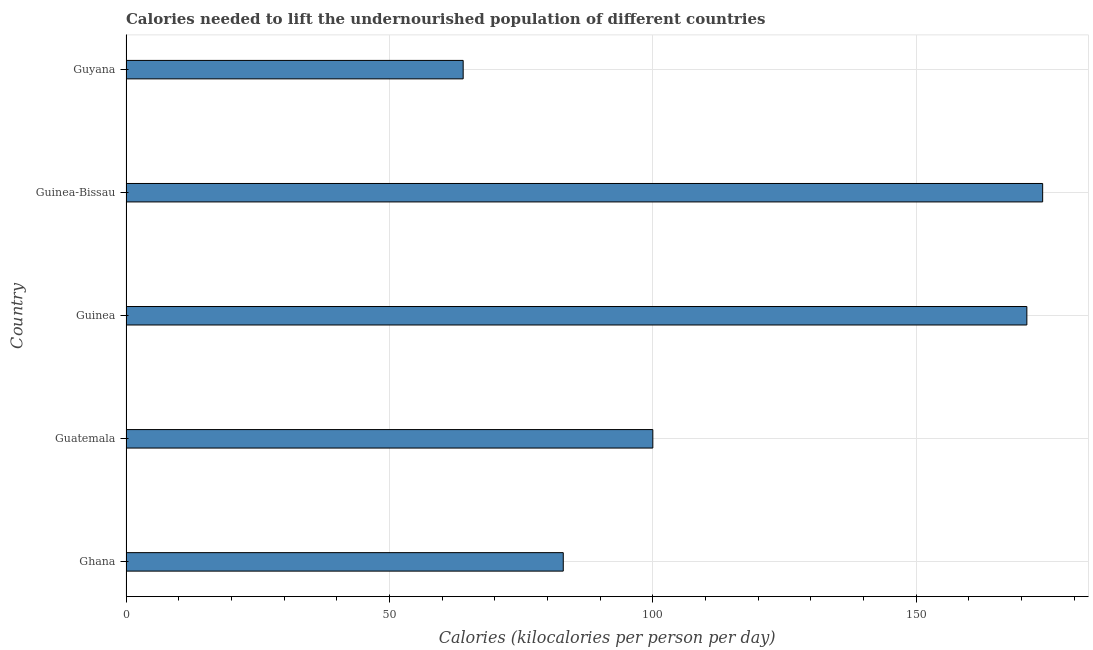Does the graph contain any zero values?
Offer a very short reply. No. What is the title of the graph?
Offer a terse response. Calories needed to lift the undernourished population of different countries. What is the label or title of the X-axis?
Provide a short and direct response. Calories (kilocalories per person per day). What is the label or title of the Y-axis?
Ensure brevity in your answer.  Country. What is the depth of food deficit in Guinea?
Provide a succinct answer. 171. Across all countries, what is the maximum depth of food deficit?
Make the answer very short. 174. Across all countries, what is the minimum depth of food deficit?
Keep it short and to the point. 64. In which country was the depth of food deficit maximum?
Your answer should be very brief. Guinea-Bissau. In which country was the depth of food deficit minimum?
Provide a succinct answer. Guyana. What is the sum of the depth of food deficit?
Offer a terse response. 592. What is the average depth of food deficit per country?
Offer a very short reply. 118.4. What is the ratio of the depth of food deficit in Guinea to that in Guyana?
Offer a very short reply. 2.67. Is the difference between the depth of food deficit in Guinea and Guinea-Bissau greater than the difference between any two countries?
Keep it short and to the point. No. Is the sum of the depth of food deficit in Ghana and Guinea-Bissau greater than the maximum depth of food deficit across all countries?
Give a very brief answer. Yes. What is the difference between the highest and the lowest depth of food deficit?
Your answer should be compact. 110. In how many countries, is the depth of food deficit greater than the average depth of food deficit taken over all countries?
Your response must be concise. 2. Are all the bars in the graph horizontal?
Offer a terse response. Yes. How many countries are there in the graph?
Provide a succinct answer. 5. What is the difference between two consecutive major ticks on the X-axis?
Give a very brief answer. 50. Are the values on the major ticks of X-axis written in scientific E-notation?
Your response must be concise. No. What is the Calories (kilocalories per person per day) of Guinea?
Your answer should be compact. 171. What is the Calories (kilocalories per person per day) in Guinea-Bissau?
Give a very brief answer. 174. What is the difference between the Calories (kilocalories per person per day) in Ghana and Guinea?
Make the answer very short. -88. What is the difference between the Calories (kilocalories per person per day) in Ghana and Guinea-Bissau?
Your answer should be very brief. -91. What is the difference between the Calories (kilocalories per person per day) in Ghana and Guyana?
Ensure brevity in your answer.  19. What is the difference between the Calories (kilocalories per person per day) in Guatemala and Guinea?
Offer a terse response. -71. What is the difference between the Calories (kilocalories per person per day) in Guatemala and Guinea-Bissau?
Offer a very short reply. -74. What is the difference between the Calories (kilocalories per person per day) in Guatemala and Guyana?
Provide a succinct answer. 36. What is the difference between the Calories (kilocalories per person per day) in Guinea and Guinea-Bissau?
Your answer should be very brief. -3. What is the difference between the Calories (kilocalories per person per day) in Guinea and Guyana?
Your response must be concise. 107. What is the difference between the Calories (kilocalories per person per day) in Guinea-Bissau and Guyana?
Your answer should be compact. 110. What is the ratio of the Calories (kilocalories per person per day) in Ghana to that in Guatemala?
Give a very brief answer. 0.83. What is the ratio of the Calories (kilocalories per person per day) in Ghana to that in Guinea?
Your answer should be very brief. 0.48. What is the ratio of the Calories (kilocalories per person per day) in Ghana to that in Guinea-Bissau?
Offer a terse response. 0.48. What is the ratio of the Calories (kilocalories per person per day) in Ghana to that in Guyana?
Ensure brevity in your answer.  1.3. What is the ratio of the Calories (kilocalories per person per day) in Guatemala to that in Guinea?
Offer a very short reply. 0.58. What is the ratio of the Calories (kilocalories per person per day) in Guatemala to that in Guinea-Bissau?
Make the answer very short. 0.57. What is the ratio of the Calories (kilocalories per person per day) in Guatemala to that in Guyana?
Your answer should be very brief. 1.56. What is the ratio of the Calories (kilocalories per person per day) in Guinea to that in Guinea-Bissau?
Your answer should be very brief. 0.98. What is the ratio of the Calories (kilocalories per person per day) in Guinea to that in Guyana?
Provide a succinct answer. 2.67. What is the ratio of the Calories (kilocalories per person per day) in Guinea-Bissau to that in Guyana?
Keep it short and to the point. 2.72. 